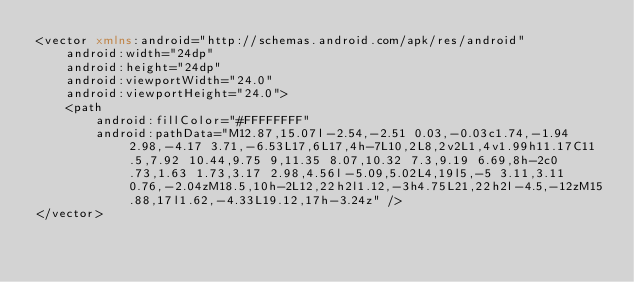<code> <loc_0><loc_0><loc_500><loc_500><_XML_><vector xmlns:android="http://schemas.android.com/apk/res/android"
    android:width="24dp"
    android:height="24dp"
    android:viewportWidth="24.0"
    android:viewportHeight="24.0">
    <path
        android:fillColor="#FFFFFFFF"
        android:pathData="M12.87,15.07l-2.54,-2.51 0.03,-0.03c1.74,-1.94 2.98,-4.17 3.71,-6.53L17,6L17,4h-7L10,2L8,2v2L1,4v1.99h11.17C11.5,7.92 10.44,9.75 9,11.35 8.07,10.32 7.3,9.19 6.69,8h-2c0.73,1.63 1.73,3.17 2.98,4.56l-5.09,5.02L4,19l5,-5 3.11,3.11 0.76,-2.04zM18.5,10h-2L12,22h2l1.12,-3h4.75L21,22h2l-4.5,-12zM15.88,17l1.62,-4.33L19.12,17h-3.24z" />
</vector>
</code> 